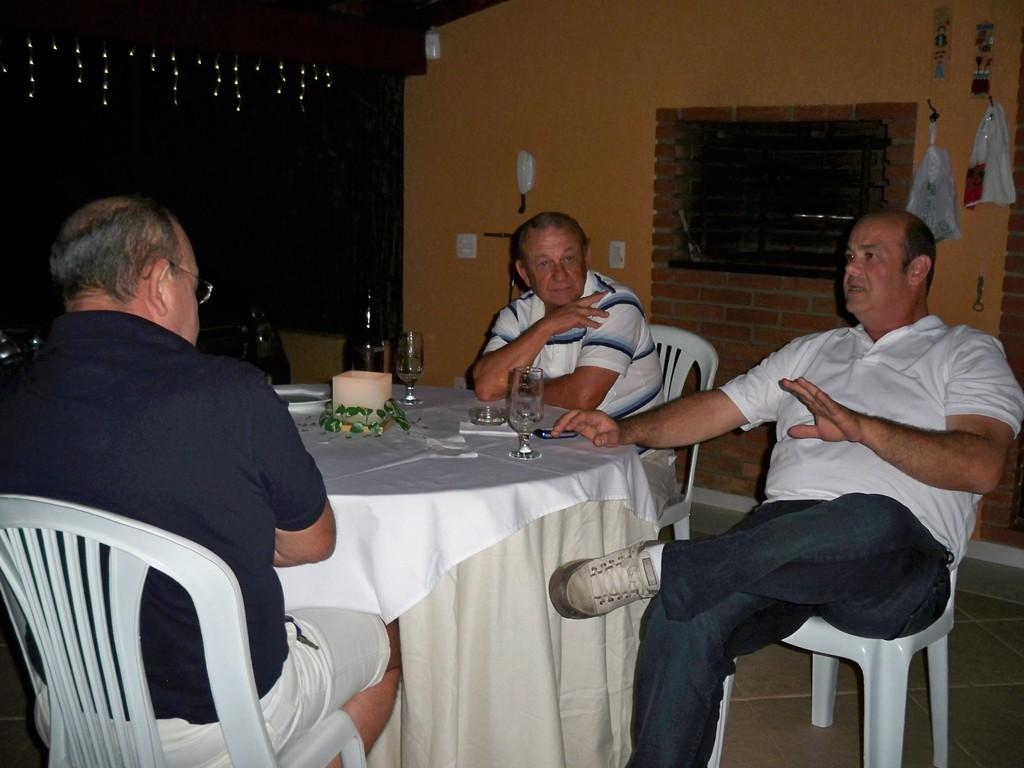How many men are present in the image? There are three men in the image. What are the men doing in the image? The men are sitting. What objects can be seen on the table in the image? There are two glasses and two bottles on a table. What can be seen in the background of the image? There is a wall, a window, and a carry bag in the background. What type of pump is visible in the image? There is no pump present in the image. How many beans are on the table in the image? There are no beans present in the image. 